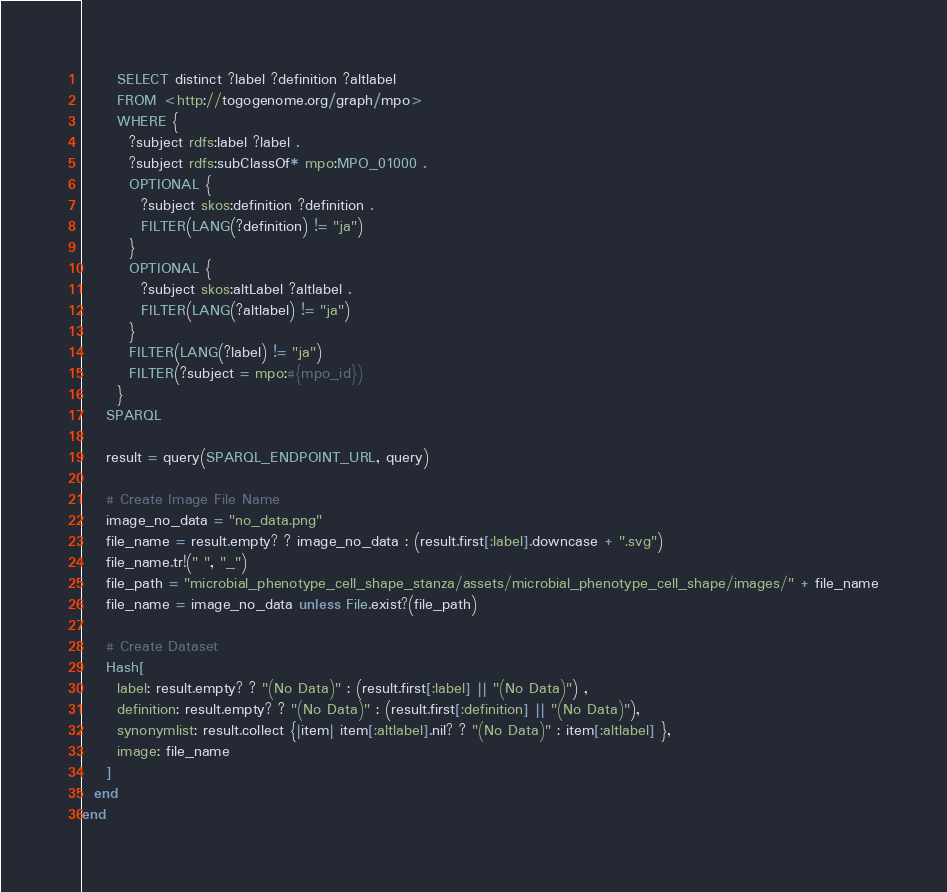<code> <loc_0><loc_0><loc_500><loc_500><_Ruby_>      SELECT distinct ?label ?definition ?altlabel
      FROM <http://togogenome.org/graph/mpo>
      WHERE {
        ?subject rdfs:label ?label .
        ?subject rdfs:subClassOf* mpo:MPO_01000 .
        OPTIONAL {
          ?subject skos:definition ?definition .
          FILTER(LANG(?definition) != "ja")
        }
        OPTIONAL {
          ?subject skos:altLabel ?altlabel .
          FILTER(LANG(?altlabel) != "ja")
        }
        FILTER(LANG(?label) != "ja")
        FILTER(?subject = mpo:#{mpo_id})
      }
    SPARQL

    result = query(SPARQL_ENDPOINT_URL, query)

    # Create Image File Name
    image_no_data = "no_data.png"
    file_name = result.empty? ? image_no_data : (result.first[:label].downcase + ".svg")
    file_name.tr!(" ", "_")
    file_path = "microbial_phenotype_cell_shape_stanza/assets/microbial_phenotype_cell_shape/images/" + file_name
    file_name = image_no_data unless File.exist?(file_path)

    # Create Dataset
    Hash[
      label: result.empty? ? "(No Data)" : (result.first[:label] || "(No Data)") ,
      definition: result.empty? ? "(No Data)" : (result.first[:definition] || "(No Data)"),
      synonymlist: result.collect {|item| item[:altlabel].nil? ? "(No Data)" : item[:altlabel] },
      image: file_name
    ]
  end
end
</code> 